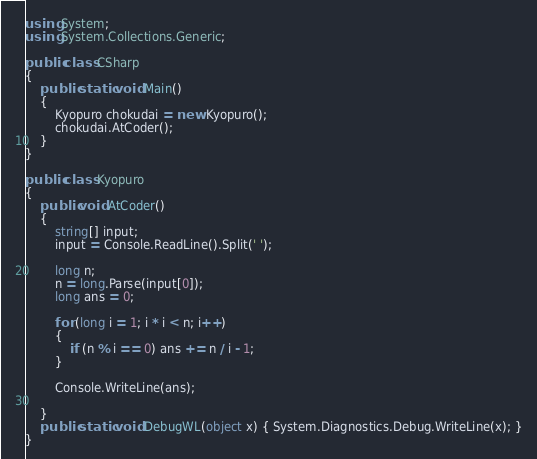Convert code to text. <code><loc_0><loc_0><loc_500><loc_500><_C#_>using System;
using System.Collections.Generic;

public class CSharp
{
    public static void Main()
    {
        Kyopuro chokudai = new Kyopuro();
        chokudai.AtCoder();
    }
}

public class Kyopuro
{
    public void AtCoder()
    {
        string[] input;
        input = Console.ReadLine().Split(' ');

        long n;
        n = long.Parse(input[0]);
        long ans = 0;

        for (long i = 1; i * i < n; i++)
        {
            if (n % i == 0) ans += n / i - 1;
        }

        Console.WriteLine(ans);

    }
    public static void DebugWL(object x) { System.Diagnostics.Debug.WriteLine(x); }
}
</code> 